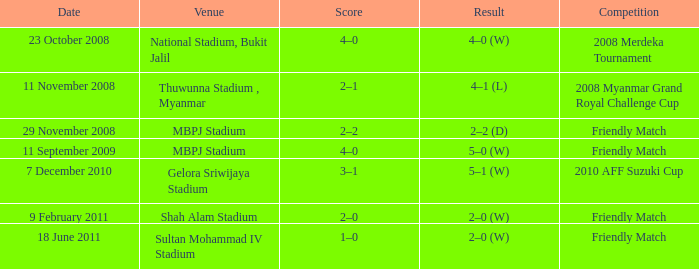What competitive event in shah alam stadium ended with a 2-0 (w) score? Friendly Match. 